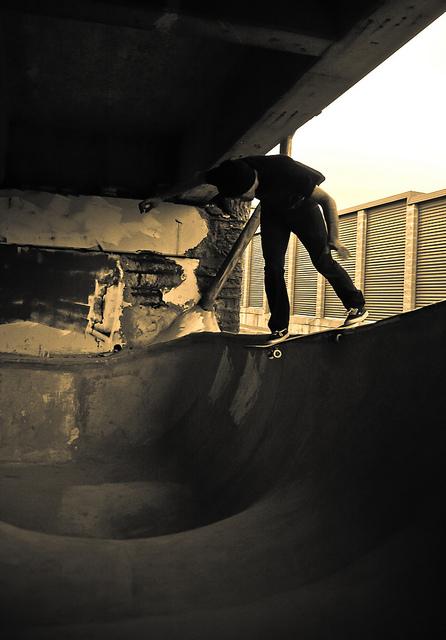How deep is this whole?
Give a very brief answer. 5 feet. How many fence panels are there?
Short answer required. 5. What makes this dangerous?
Be succinct. Concrete. Is the skateboarder airborne?
Concise answer only. No. 